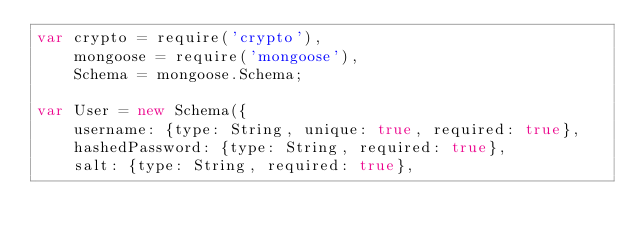<code> <loc_0><loc_0><loc_500><loc_500><_JavaScript_>var crypto = require('crypto'),
    mongoose = require('mongoose'),
    Schema = mongoose.Schema;

var User = new Schema({
    username: {type: String, unique: true, required: true},
    hashedPassword: {type: String, required: true},
    salt: {type: String, required: true},</code> 